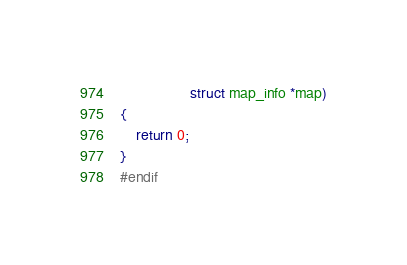Convert code to text. <code><loc_0><loc_0><loc_500><loc_500><_C_>			     struct map_info *map)
{
	return 0;
}
#endif
</code> 